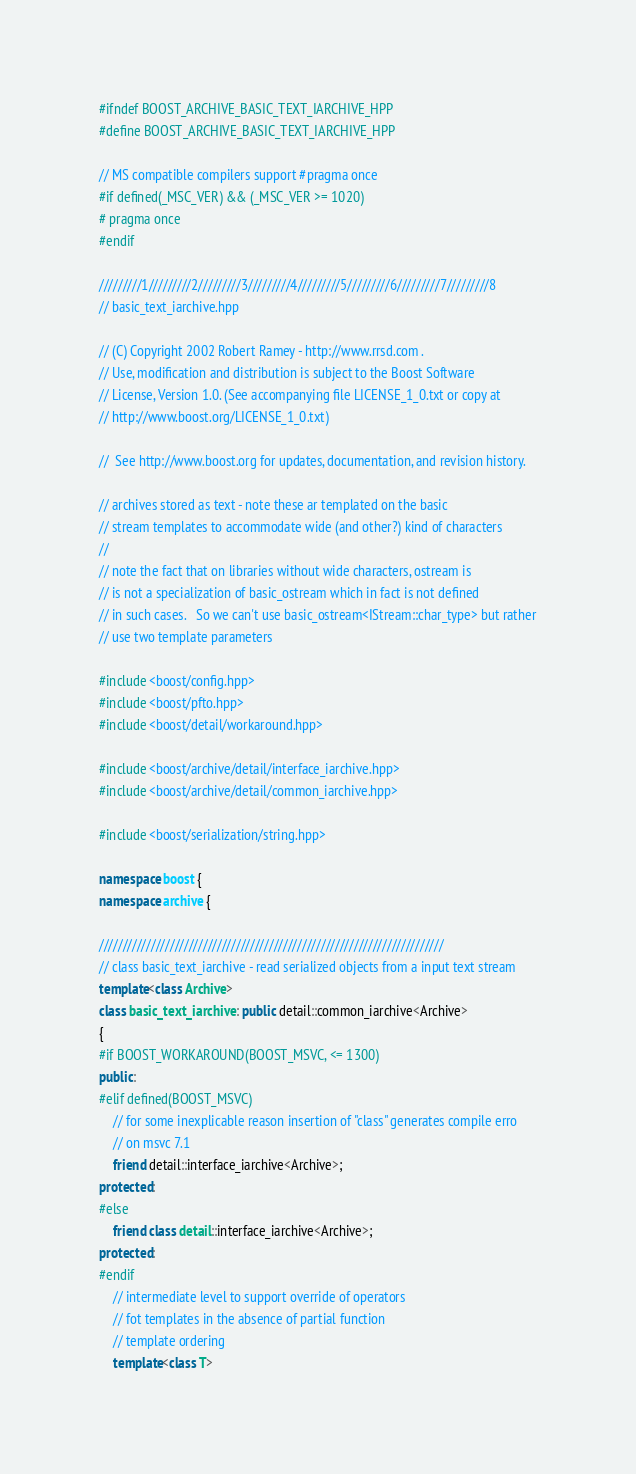<code> <loc_0><loc_0><loc_500><loc_500><_C++_>#ifndef BOOST_ARCHIVE_BASIC_TEXT_IARCHIVE_HPP
#define BOOST_ARCHIVE_BASIC_TEXT_IARCHIVE_HPP

// MS compatible compilers support #pragma once
#if defined(_MSC_VER) && (_MSC_VER >= 1020)
# pragma once
#endif

/////////1/////////2/////////3/////////4/////////5/////////6/////////7/////////8
// basic_text_iarchive.hpp

// (C) Copyright 2002 Robert Ramey - http://www.rrsd.com . 
// Use, modification and distribution is subject to the Boost Software
// License, Version 1.0. (See accompanying file LICENSE_1_0.txt or copy at
// http://www.boost.org/LICENSE_1_0.txt)

//  See http://www.boost.org for updates, documentation, and revision history.

// archives stored as text - note these ar templated on the basic
// stream templates to accommodate wide (and other?) kind of characters
//
// note the fact that on libraries without wide characters, ostream is
// is not a specialization of basic_ostream which in fact is not defined
// in such cases.   So we can't use basic_ostream<IStream::char_type> but rather
// use two template parameters

#include <boost/config.hpp>
#include <boost/pfto.hpp>
#include <boost/detail/workaround.hpp>

#include <boost/archive/detail/interface_iarchive.hpp>
#include <boost/archive/detail/common_iarchive.hpp>

#include <boost/serialization/string.hpp>

namespace boost {
namespace archive {

/////////////////////////////////////////////////////////////////////////
// class basic_text_iarchive - read serialized objects from a input text stream
template<class Archive>
class basic_text_iarchive : public detail::common_iarchive<Archive>
{
#if BOOST_WORKAROUND(BOOST_MSVC, <= 1300)
public:
#elif defined(BOOST_MSVC)
    // for some inexplicable reason insertion of "class" generates compile erro
    // on msvc 7.1
    friend detail::interface_iarchive<Archive>;
protected:
#else
    friend class detail::interface_iarchive<Archive>;
protected:
#endif
    // intermediate level to support override of operators
    // fot templates in the absence of partial function 
    // template ordering
    template<class T></code> 